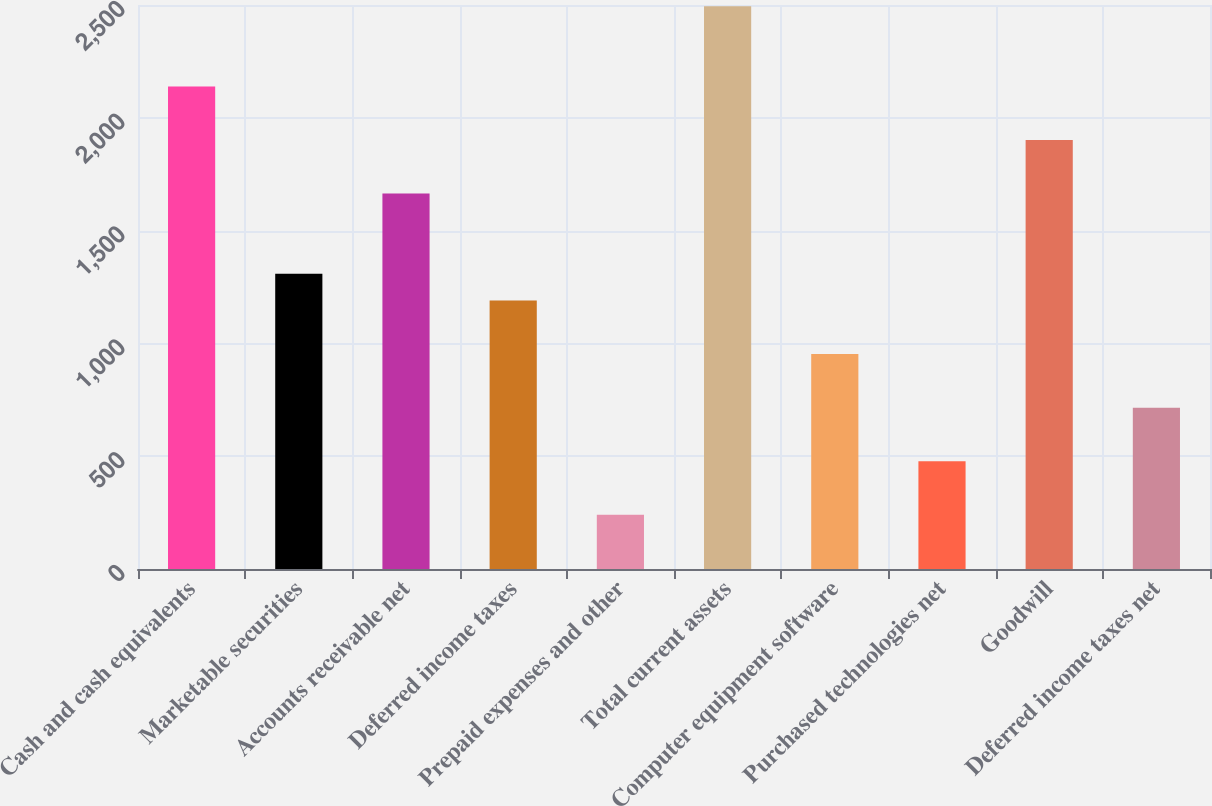Convert chart. <chart><loc_0><loc_0><loc_500><loc_500><bar_chart><fcel>Cash and cash equivalents<fcel>Marketable securities<fcel>Accounts receivable net<fcel>Deferred income taxes<fcel>Prepaid expenses and other<fcel>Total current assets<fcel>Computer equipment software<fcel>Purchased technologies net<fcel>Goodwill<fcel>Deferred income taxes net<nl><fcel>2138.58<fcel>1308.31<fcel>1664.14<fcel>1189.7<fcel>240.82<fcel>2494.41<fcel>952.48<fcel>478.04<fcel>1901.36<fcel>715.26<nl></chart> 